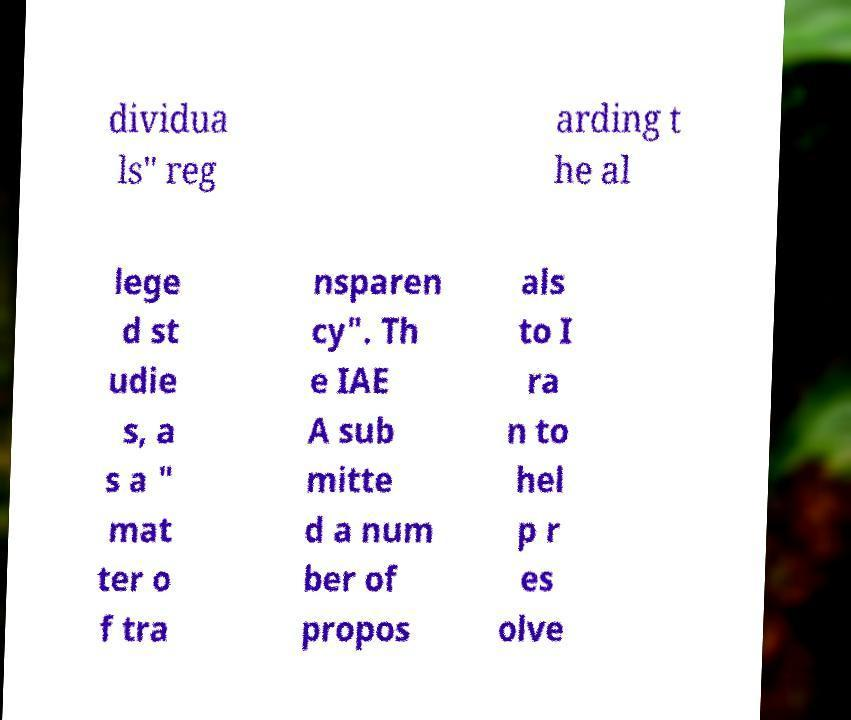There's text embedded in this image that I need extracted. Can you transcribe it verbatim? dividua ls" reg arding t he al lege d st udie s, a s a " mat ter o f tra nsparen cy". Th e IAE A sub mitte d a num ber of propos als to I ra n to hel p r es olve 